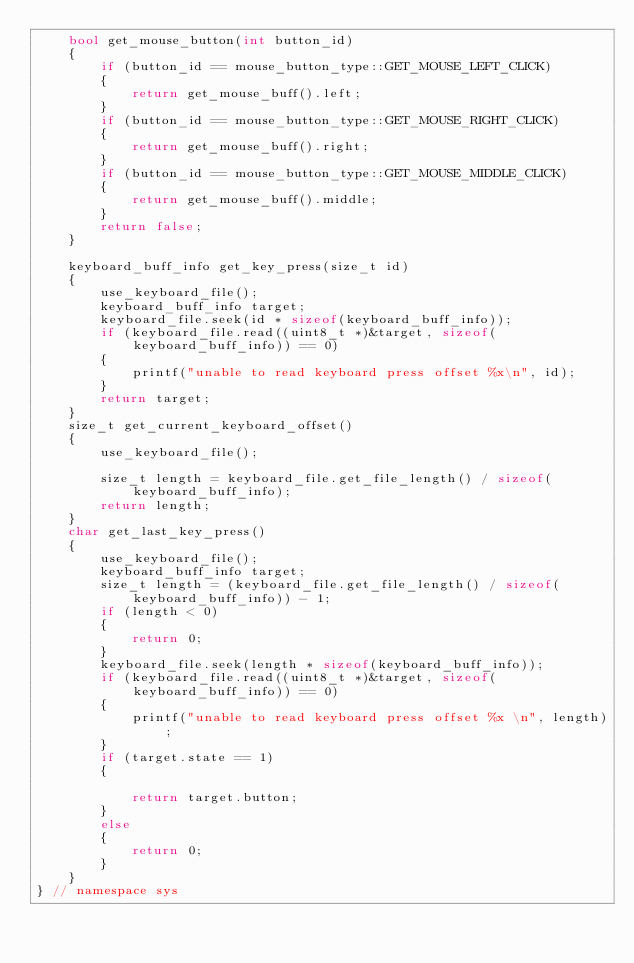Convert code to text. <code><loc_0><loc_0><loc_500><loc_500><_C++_>    bool get_mouse_button(int button_id)
    {
        if (button_id == mouse_button_type::GET_MOUSE_LEFT_CLICK)
        {
            return get_mouse_buff().left;
        }
        if (button_id == mouse_button_type::GET_MOUSE_RIGHT_CLICK)
        {
            return get_mouse_buff().right;
        }
        if (button_id == mouse_button_type::GET_MOUSE_MIDDLE_CLICK)
        {
            return get_mouse_buff().middle;
        }
        return false;
    }

    keyboard_buff_info get_key_press(size_t id)
    {
        use_keyboard_file();
        keyboard_buff_info target;
        keyboard_file.seek(id * sizeof(keyboard_buff_info));
        if (keyboard_file.read((uint8_t *)&target, sizeof(keyboard_buff_info)) == 0)
        {
            printf("unable to read keyboard press offset %x\n", id);
        }
        return target;
    }
    size_t get_current_keyboard_offset()
    {
        use_keyboard_file();

        size_t length = keyboard_file.get_file_length() / sizeof(keyboard_buff_info);
        return length;
    }
    char get_last_key_press()
    {
        use_keyboard_file();
        keyboard_buff_info target;
        size_t length = (keyboard_file.get_file_length() / sizeof(keyboard_buff_info)) - 1;
        if (length < 0)
        {
            return 0;
        }
        keyboard_file.seek(length * sizeof(keyboard_buff_info));
        if (keyboard_file.read((uint8_t *)&target, sizeof(keyboard_buff_info)) == 0)
        {
            printf("unable to read keyboard press offset %x \n", length);
        }
        if (target.state == 1)
        {

            return target.button;
        }
        else
        {
            return 0;
        }
    }
} // namespace sys
</code> 